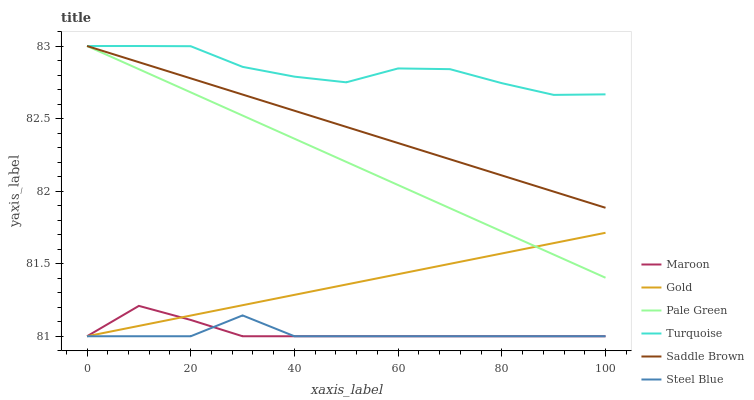Does Steel Blue have the minimum area under the curve?
Answer yes or no. Yes. Does Turquoise have the maximum area under the curve?
Answer yes or no. Yes. Does Gold have the minimum area under the curve?
Answer yes or no. No. Does Gold have the maximum area under the curve?
Answer yes or no. No. Is Gold the smoothest?
Answer yes or no. Yes. Is Turquoise the roughest?
Answer yes or no. Yes. Is Steel Blue the smoothest?
Answer yes or no. No. Is Steel Blue the roughest?
Answer yes or no. No. Does Gold have the lowest value?
Answer yes or no. Yes. Does Pale Green have the lowest value?
Answer yes or no. No. Does Saddle Brown have the highest value?
Answer yes or no. Yes. Does Gold have the highest value?
Answer yes or no. No. Is Steel Blue less than Pale Green?
Answer yes or no. Yes. Is Turquoise greater than Steel Blue?
Answer yes or no. Yes. Does Turquoise intersect Pale Green?
Answer yes or no. Yes. Is Turquoise less than Pale Green?
Answer yes or no. No. Is Turquoise greater than Pale Green?
Answer yes or no. No. Does Steel Blue intersect Pale Green?
Answer yes or no. No. 